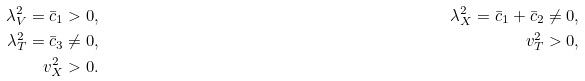Convert formula to latex. <formula><loc_0><loc_0><loc_500><loc_500>\lambda _ { V } ^ { 2 } = \bar { c } _ { 1 } & > 0 , \quad & \lambda _ { X } ^ { 2 } = \bar { c } _ { 1 } + \bar { c } _ { 2 } \ne 0 , \\ \lambda _ { T } ^ { 2 } = \bar { c } _ { 3 } & \ne 0 , \quad & v _ { T } ^ { 2 } > 0 , \\ v _ { X } ^ { 2 } & > 0 . \quad &</formula> 